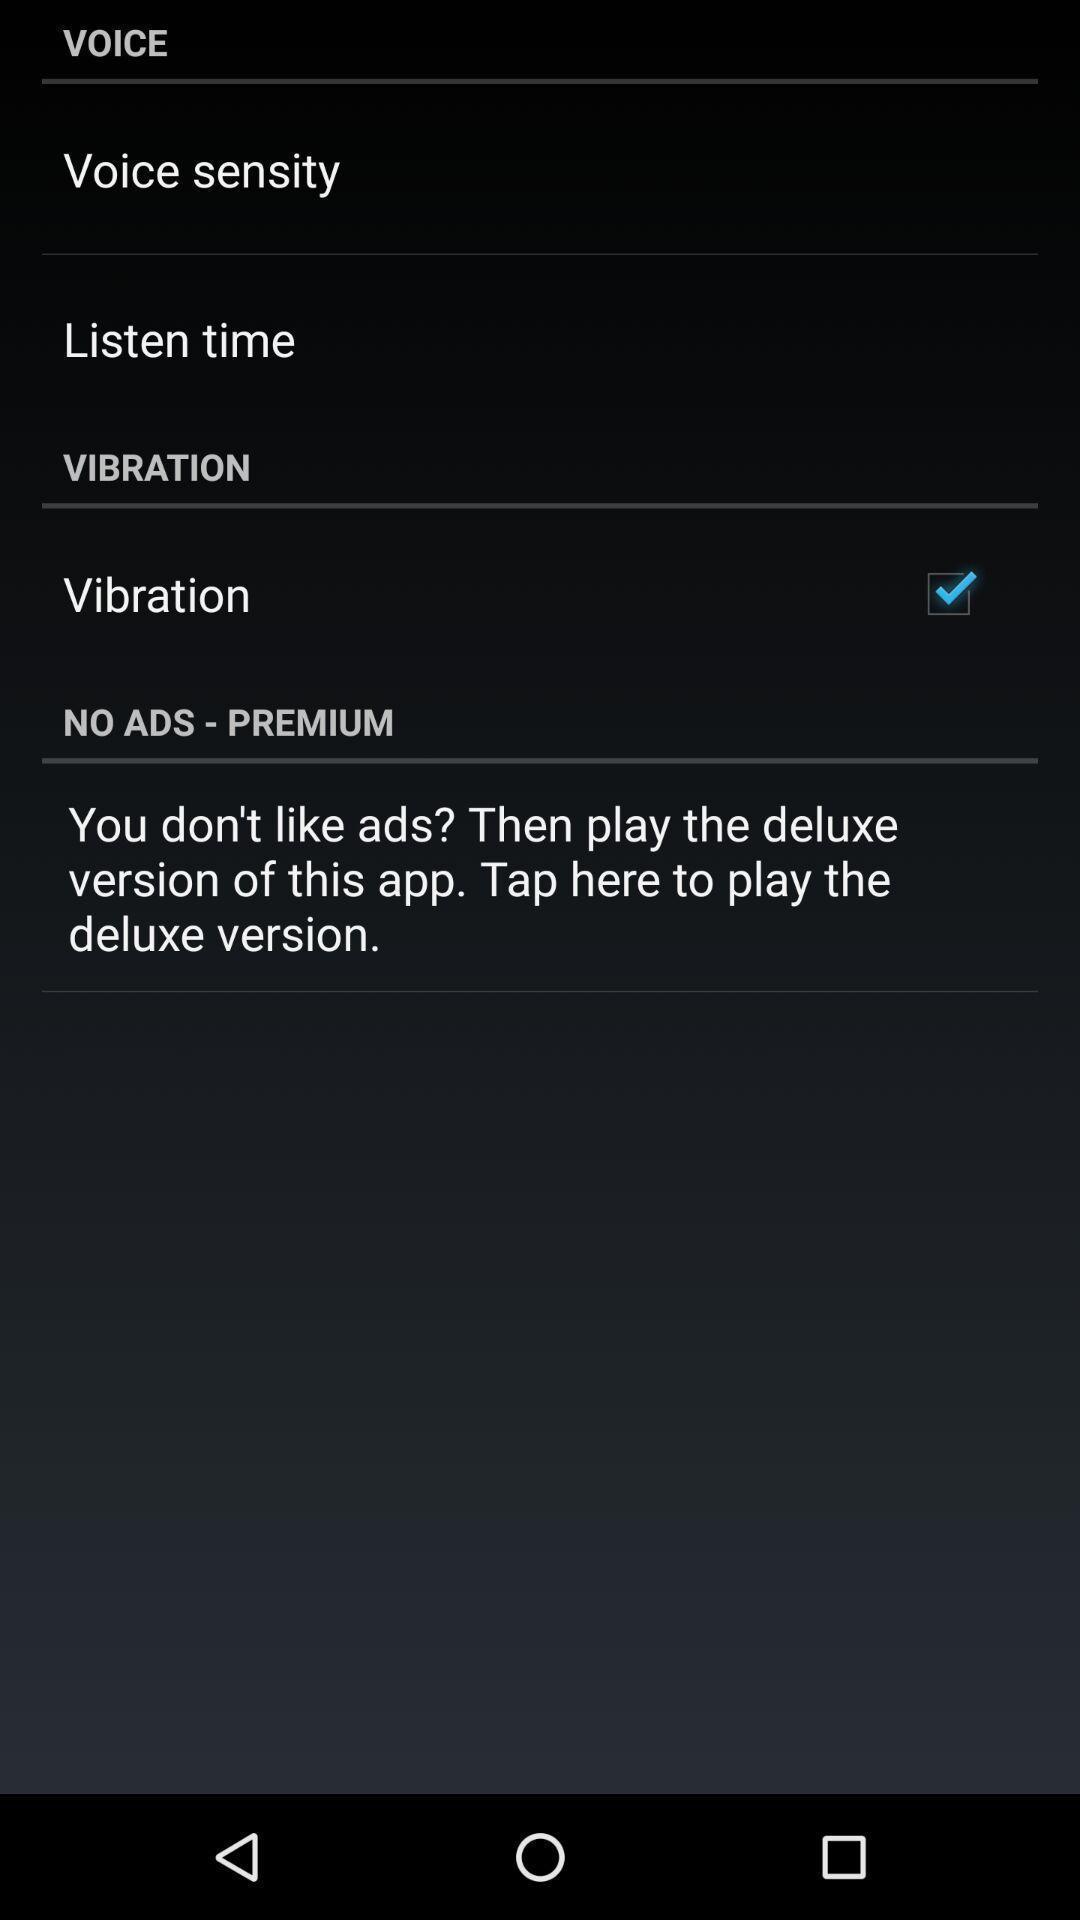Please provide a description for this image. Screen showing various setting options. What can you discern from this picture? Voice settings in the application. 